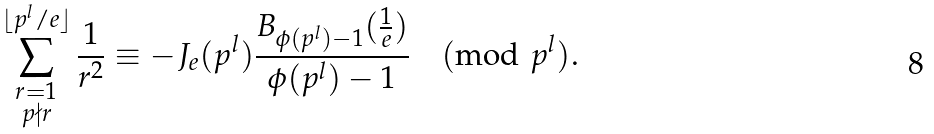Convert formula to latex. <formula><loc_0><loc_0><loc_500><loc_500>\sum ^ { \lfloor p ^ { l } / e \rfloor } _ { \substack { r = 1 \\ p \nmid r } } \frac { 1 } { r ^ { 2 } } \equiv - J _ { e } ( p ^ { l } ) \frac { B _ { \phi ( p ^ { l } ) - 1 } ( \frac { 1 } { e } ) } { \phi ( p ^ { l } ) - 1 } \pmod { p ^ { l } } .</formula> 